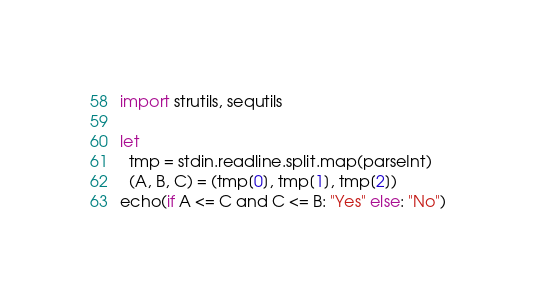<code> <loc_0><loc_0><loc_500><loc_500><_Nim_>import strutils, sequtils

let
  tmp = stdin.readline.split.map(parseInt)
  (A, B, C) = (tmp[0], tmp[1], tmp[2])
echo(if A <= C and C <= B: "Yes" else: "No")
</code> 